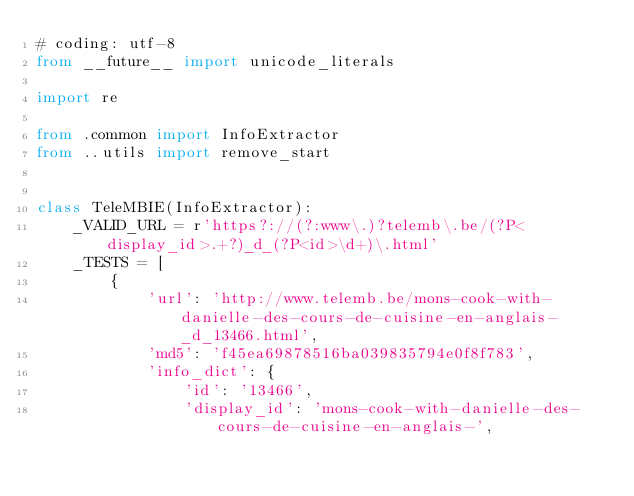Convert code to text. <code><loc_0><loc_0><loc_500><loc_500><_Python_># coding: utf-8
from __future__ import unicode_literals

import re

from .common import InfoExtractor
from ..utils import remove_start


class TeleMBIE(InfoExtractor):
    _VALID_URL = r'https?://(?:www\.)?telemb\.be/(?P<display_id>.+?)_d_(?P<id>\d+)\.html'
    _TESTS = [
        {
            'url': 'http://www.telemb.be/mons-cook-with-danielle-des-cours-de-cuisine-en-anglais-_d_13466.html',
            'md5': 'f45ea69878516ba039835794e0f8f783',
            'info_dict': {
                'id': '13466',
                'display_id': 'mons-cook-with-danielle-des-cours-de-cuisine-en-anglais-',</code> 